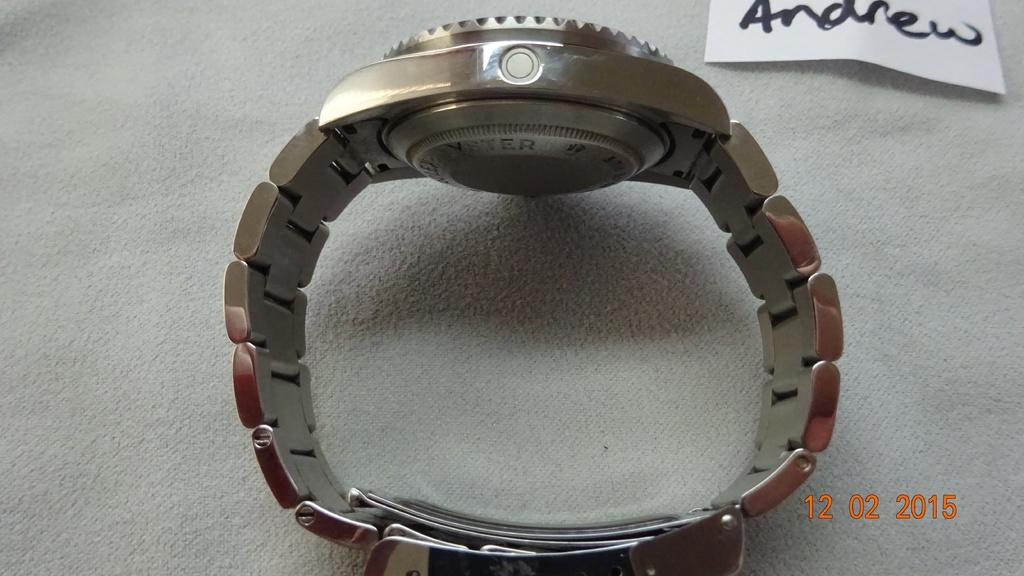<image>
Present a compact description of the photo's key features. A silver watch is on it's band, facing a piece of paper, above it that has the name Andrew on it. 